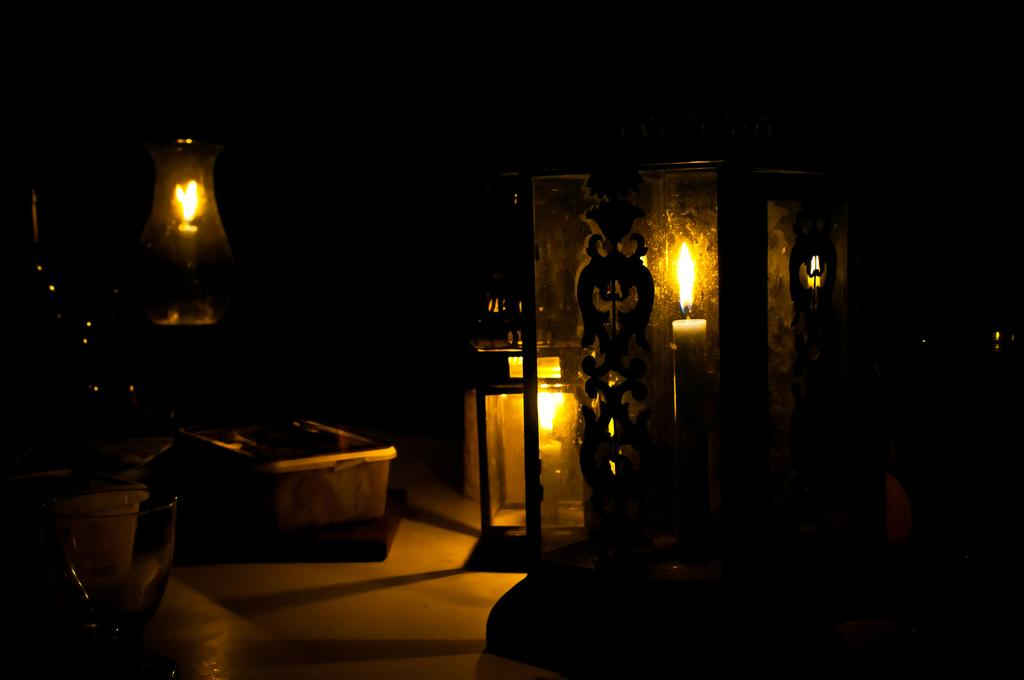What is present in the image that produces light? There are lighted candles in the image. What type of container is visible in the image? There is a box in the image. What type of drinking vessel is present in the image? There is a glass in the image? How would you describe the lighting conditions in the image? The background of the image is dark. What is the tendency of the spade in the image? There is no spade present in the image. How does the disgust factor contribute to the image? There is no indication of disgust in the image, as it features lighted candles, a box, a glass, and other objects against a dark background. 